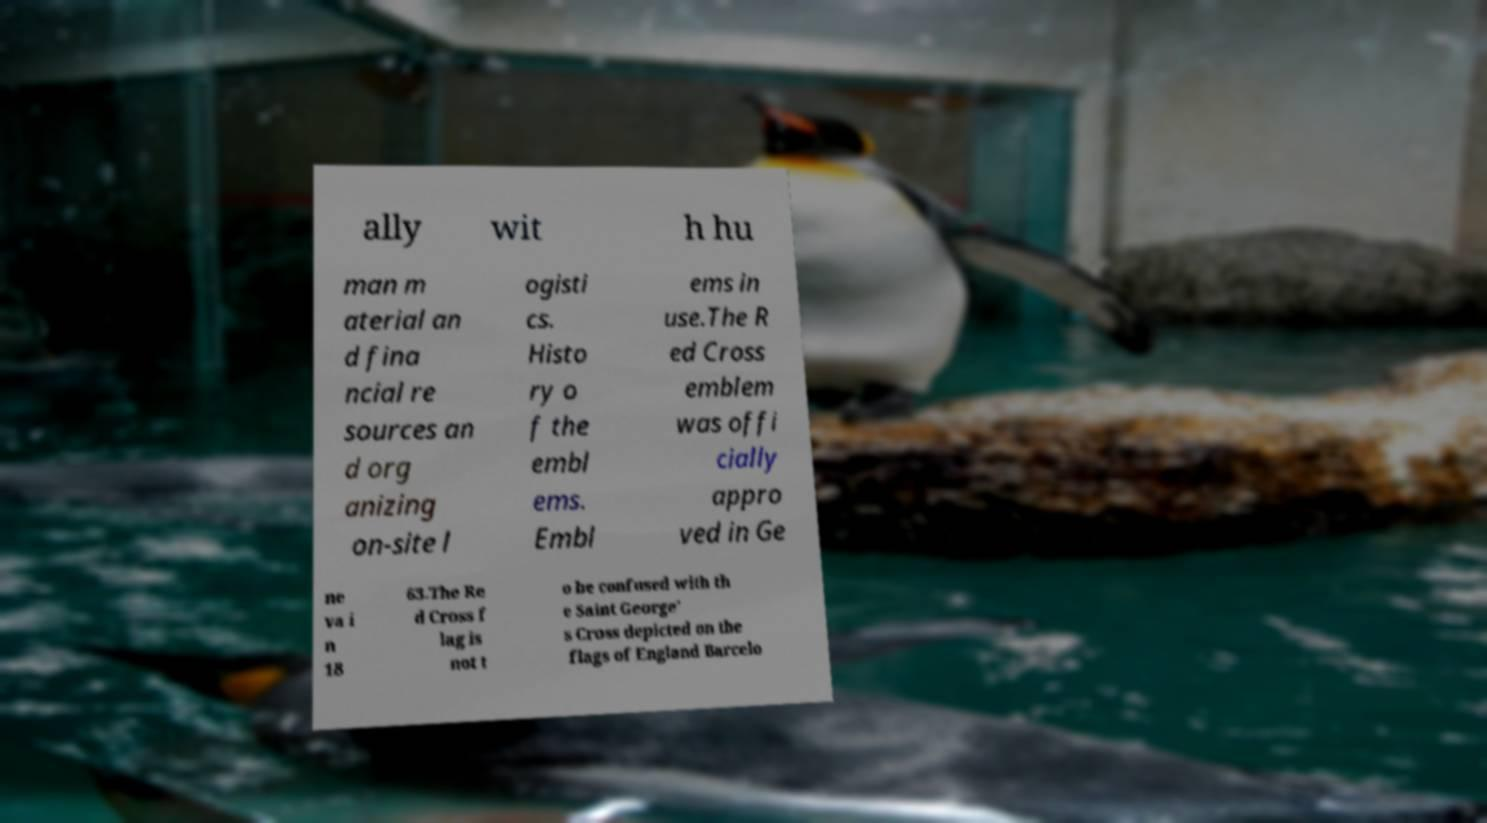Could you extract and type out the text from this image? ally wit h hu man m aterial an d fina ncial re sources an d org anizing on-site l ogisti cs. Histo ry o f the embl ems. Embl ems in use.The R ed Cross emblem was offi cially appro ved in Ge ne va i n 18 63.The Re d Cross f lag is not t o be confused with th e Saint George' s Cross depicted on the flags of England Barcelo 